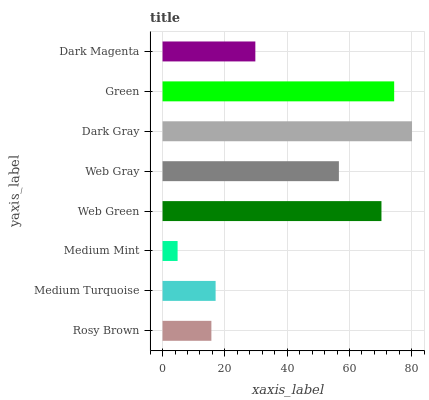Is Medium Mint the minimum?
Answer yes or no. Yes. Is Dark Gray the maximum?
Answer yes or no. Yes. Is Medium Turquoise the minimum?
Answer yes or no. No. Is Medium Turquoise the maximum?
Answer yes or no. No. Is Medium Turquoise greater than Rosy Brown?
Answer yes or no. Yes. Is Rosy Brown less than Medium Turquoise?
Answer yes or no. Yes. Is Rosy Brown greater than Medium Turquoise?
Answer yes or no. No. Is Medium Turquoise less than Rosy Brown?
Answer yes or no. No. Is Web Gray the high median?
Answer yes or no. Yes. Is Dark Magenta the low median?
Answer yes or no. Yes. Is Dark Gray the high median?
Answer yes or no. No. Is Rosy Brown the low median?
Answer yes or no. No. 